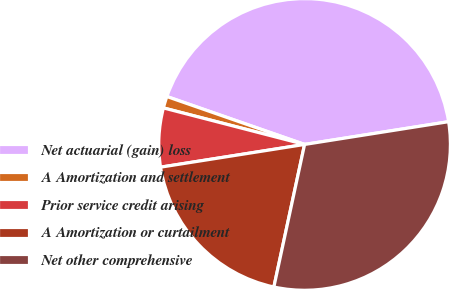Convert chart to OTSL. <chart><loc_0><loc_0><loc_500><loc_500><pie_chart><fcel>Net actuarial (gain) loss<fcel>A Amortization and settlement<fcel>Prior service credit arising<fcel>A Amortization or curtailment<fcel>Net other comprehensive<nl><fcel>42.17%<fcel>1.3%<fcel>6.52%<fcel>19.13%<fcel>30.87%<nl></chart> 